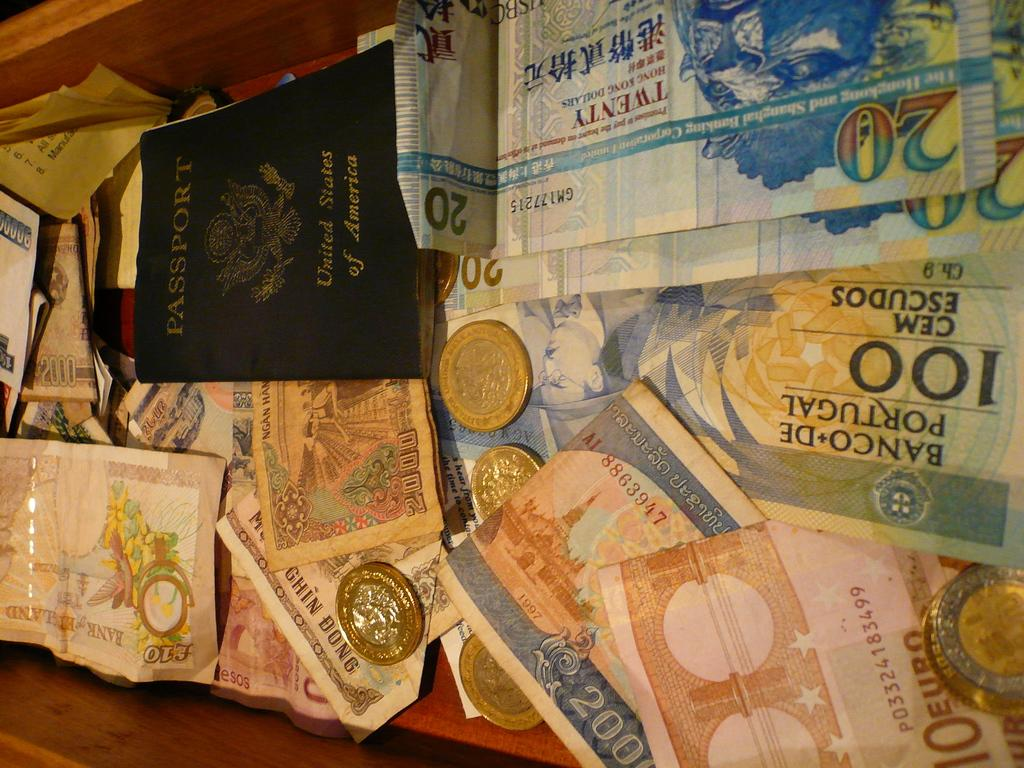<image>
Give a short and clear explanation of the subsequent image. A lot of currency is on the table as well as a United States passport. 